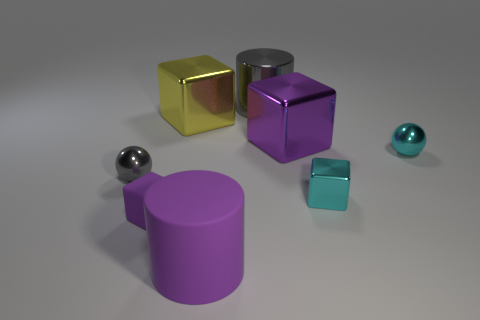How many large things are spheres or purple things?
Keep it short and to the point. 2. Are there any large purple metallic cylinders?
Make the answer very short. No. What size is the cylinder that is the same material as the big yellow cube?
Ensure brevity in your answer.  Large. Is the large gray cylinder made of the same material as the large purple block?
Offer a very short reply. Yes. What number of other objects are there of the same material as the small gray thing?
Make the answer very short. 5. How many shiny objects are both on the right side of the small purple rubber object and on the left side of the large gray thing?
Ensure brevity in your answer.  1. The shiny cylinder has what color?
Make the answer very short. Gray. What is the material of the cyan object that is the same shape as the purple metal thing?
Offer a terse response. Metal. Is the matte block the same color as the rubber cylinder?
Give a very brief answer. Yes. What is the shape of the small purple matte object that is left of the purple cube on the right side of the purple cylinder?
Your response must be concise. Cube. 